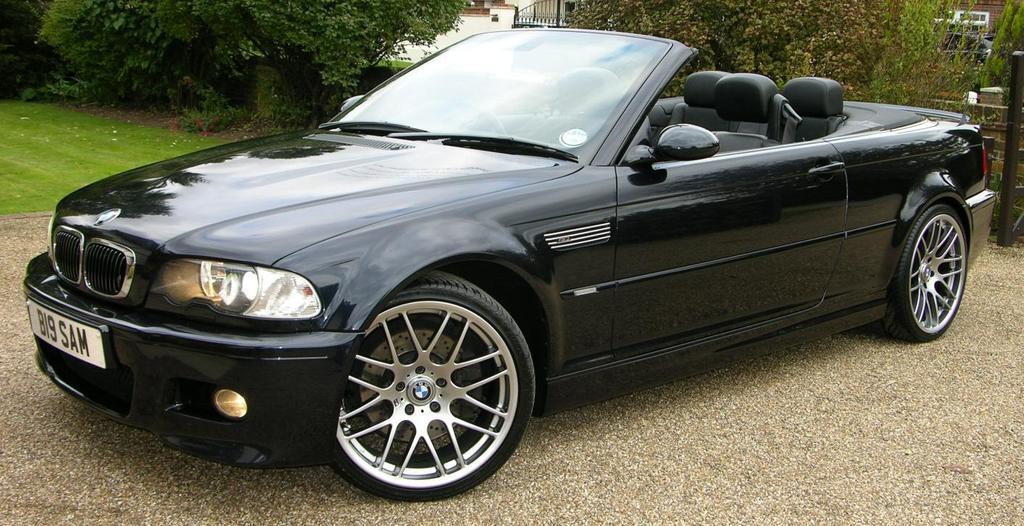Can you describe this image briefly? In this image we can see a black color car parked on the road. In the background we can see many trees. 